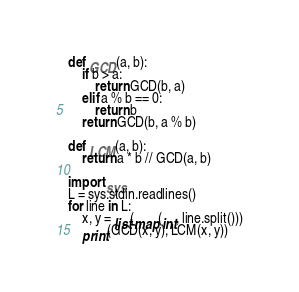Convert code to text. <code><loc_0><loc_0><loc_500><loc_500><_Python_>def GCD(a, b):
	if b > a:
		return GCD(b, a)
	elif a % b == 0:
		return b
	return GCD(b, a % b)
		
def LCM(a, b):
	return a * b // GCD(a, b)

import sys
L = sys.stdin.readlines()
for line in L:
	x, y = list(map(int, line.split()))
	print(GCD(x, y), LCM(x, y))</code> 